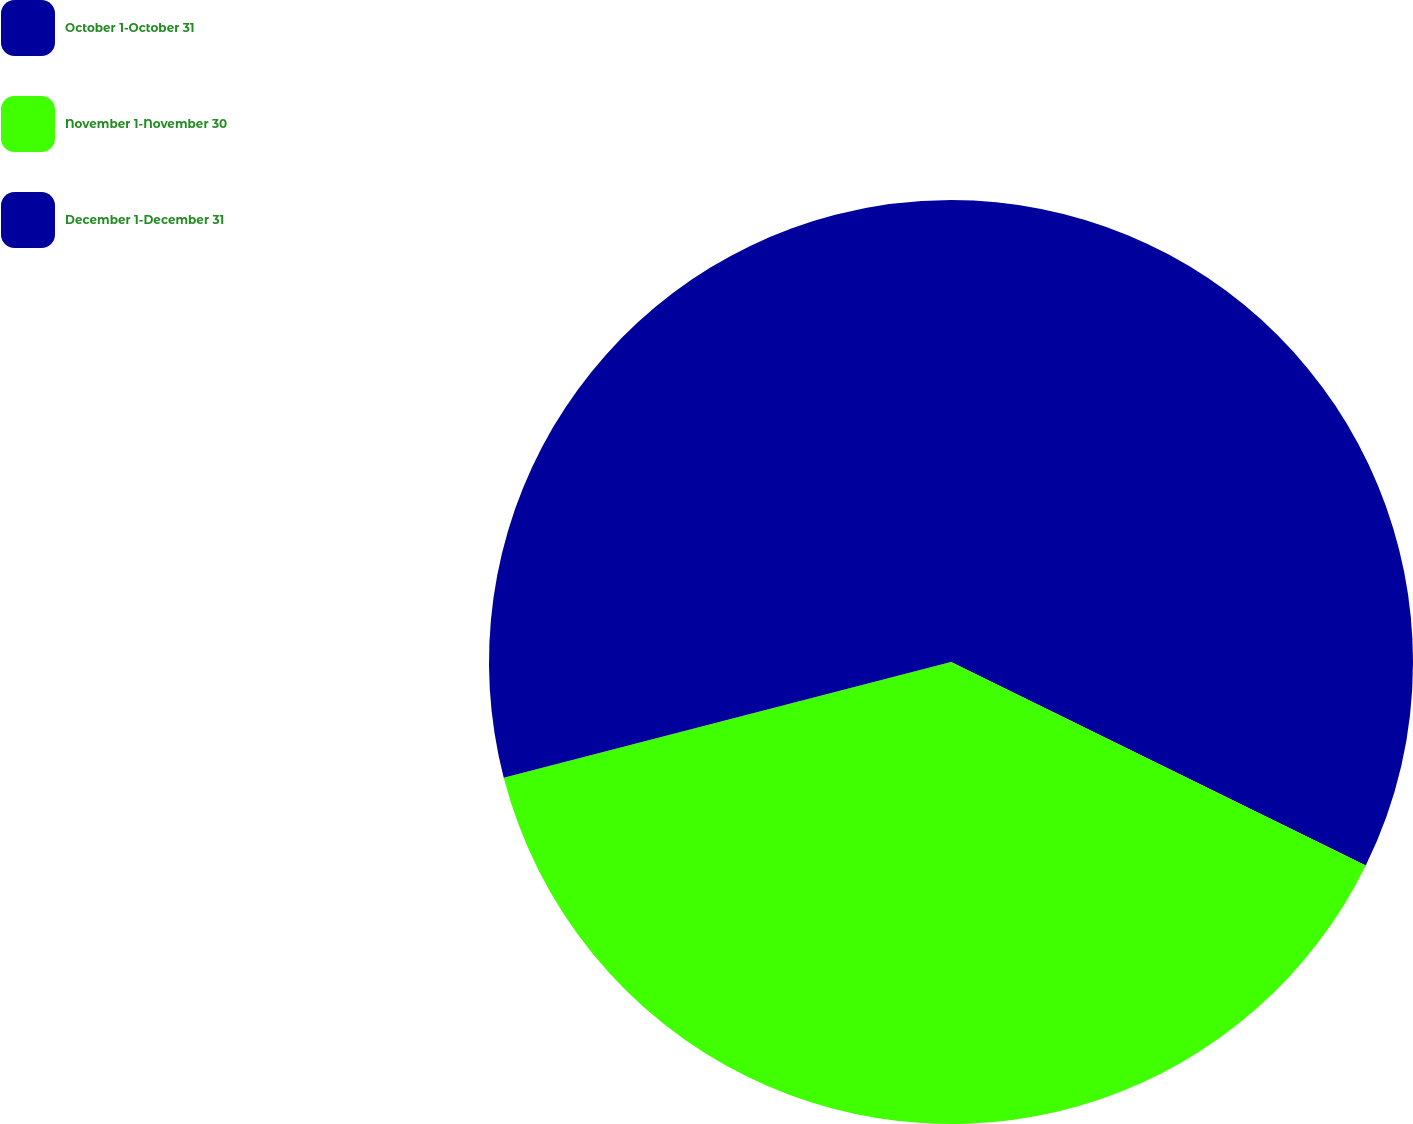Convert chart. <chart><loc_0><loc_0><loc_500><loc_500><pie_chart><fcel>October 1-October 31<fcel>November 1-November 30<fcel>December 1-December 31<nl><fcel>32.26%<fcel>38.71%<fcel>29.03%<nl></chart> 